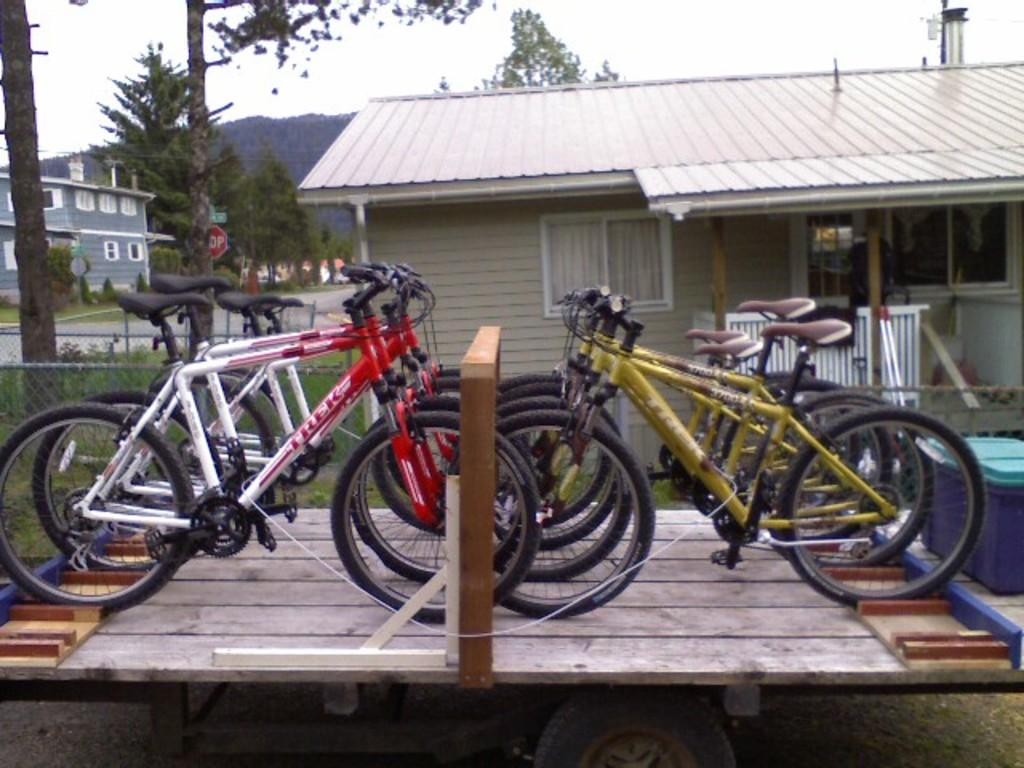What type of structures can be seen in the image? There are houses in the image. What type of vegetation is present in the image? There are trees in the image. What mode of transportation can be seen in the image? There are bicycles placed in one place in the image. What type of tray is being used to sort the approval documents in the image? There is no tray, sorting, or approval documents present in the image. 